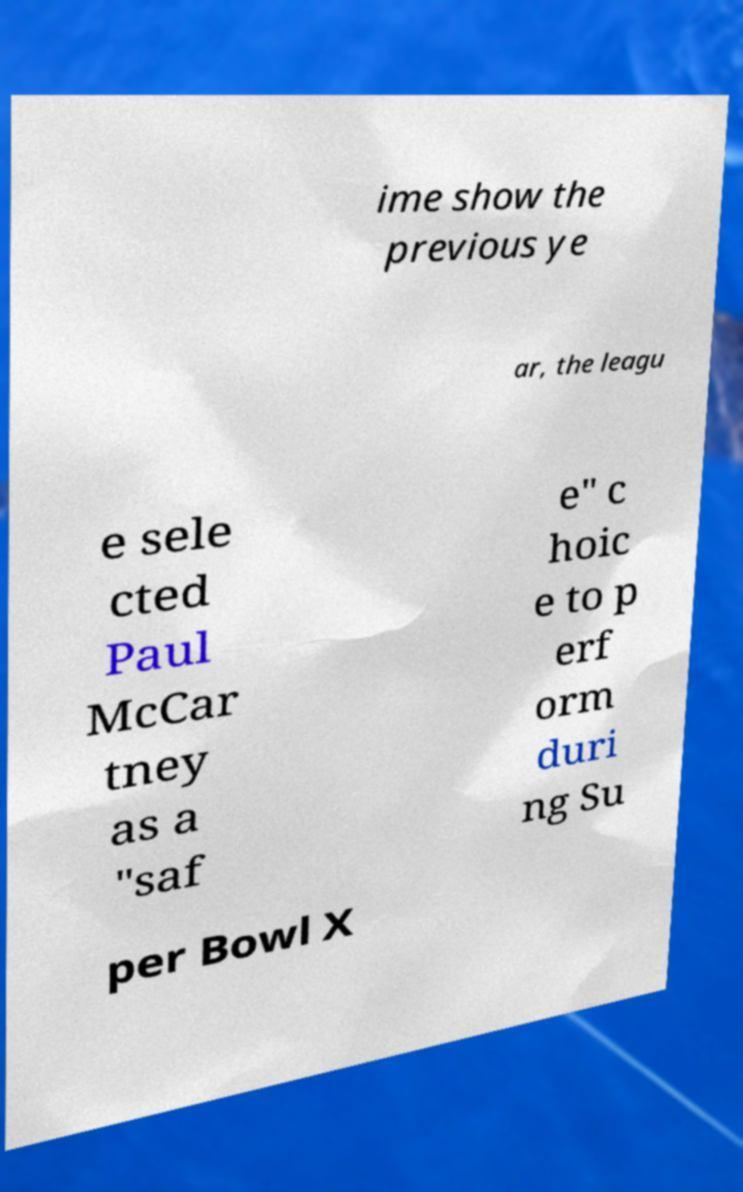For documentation purposes, I need the text within this image transcribed. Could you provide that? ime show the previous ye ar, the leagu e sele cted Paul McCar tney as a "saf e" c hoic e to p erf orm duri ng Su per Bowl X 